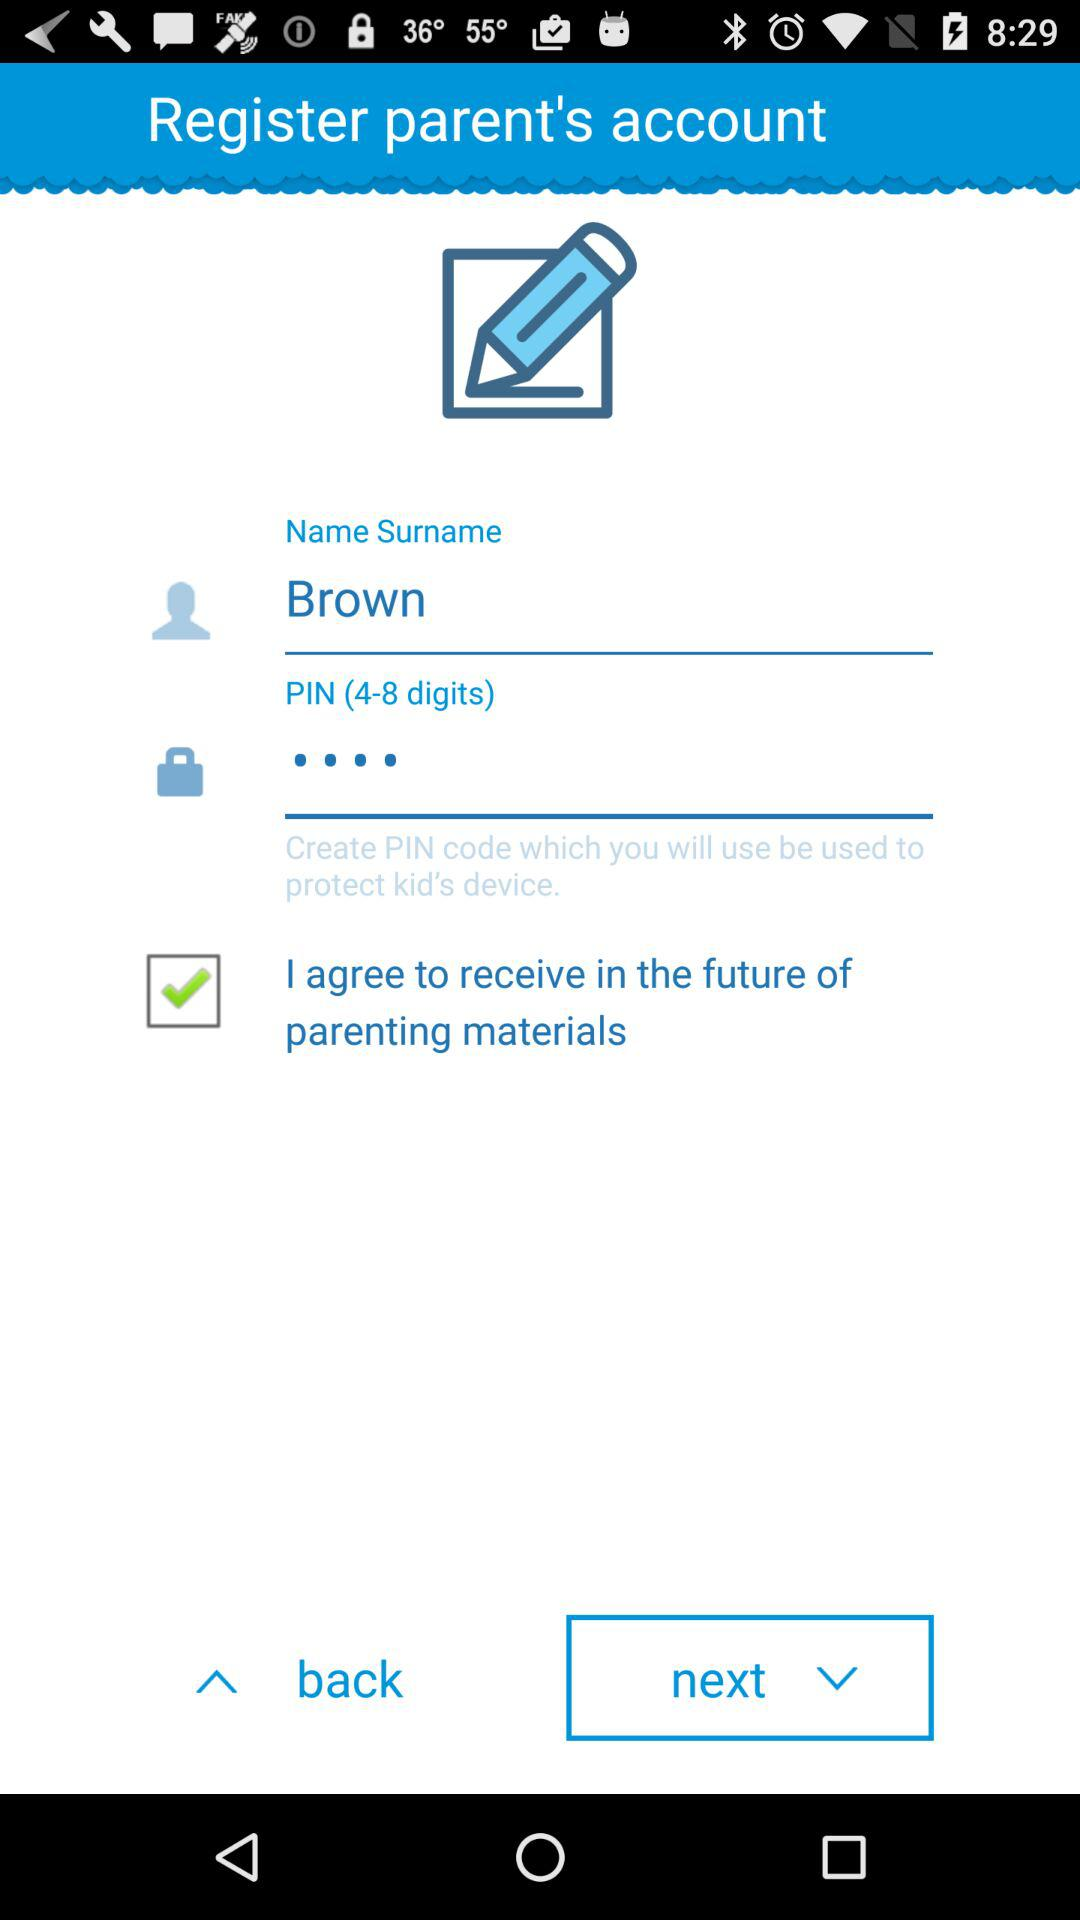Is "I agree to receive in the future of parenting materials" checked or unchecked? "I agree to receive in the future of parenting materials" is checked. 